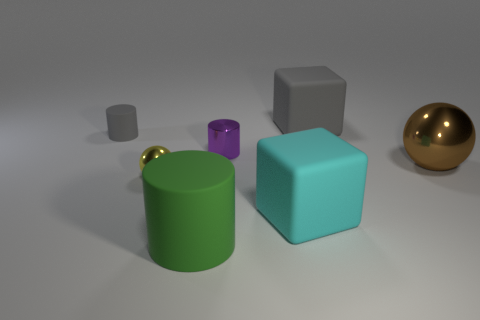What is the size of the other object that is the same color as the small rubber object?
Give a very brief answer. Large. There is a big thing that is the same color as the small matte thing; what is its material?
Offer a terse response. Rubber. What is the material of the other thing that is the same shape as the brown thing?
Give a very brief answer. Metal. The brown shiny thing has what shape?
Provide a succinct answer. Sphere. What is the color of the shiny thing that is behind the shiny thing that is on the right side of the big gray object?
Offer a very short reply. Purple. What size is the shiny thing to the left of the purple shiny thing?
Provide a short and direct response. Small. Are there any big cylinders that have the same material as the gray cube?
Your answer should be very brief. Yes. What number of other matte things are the same shape as the yellow thing?
Your answer should be very brief. 0. What is the shape of the gray matte thing that is right of the shiny ball in front of the metallic sphere on the right side of the big green thing?
Your answer should be very brief. Cube. There is a small thing that is on the left side of the green matte object and behind the big brown sphere; what is it made of?
Your answer should be very brief. Rubber. 